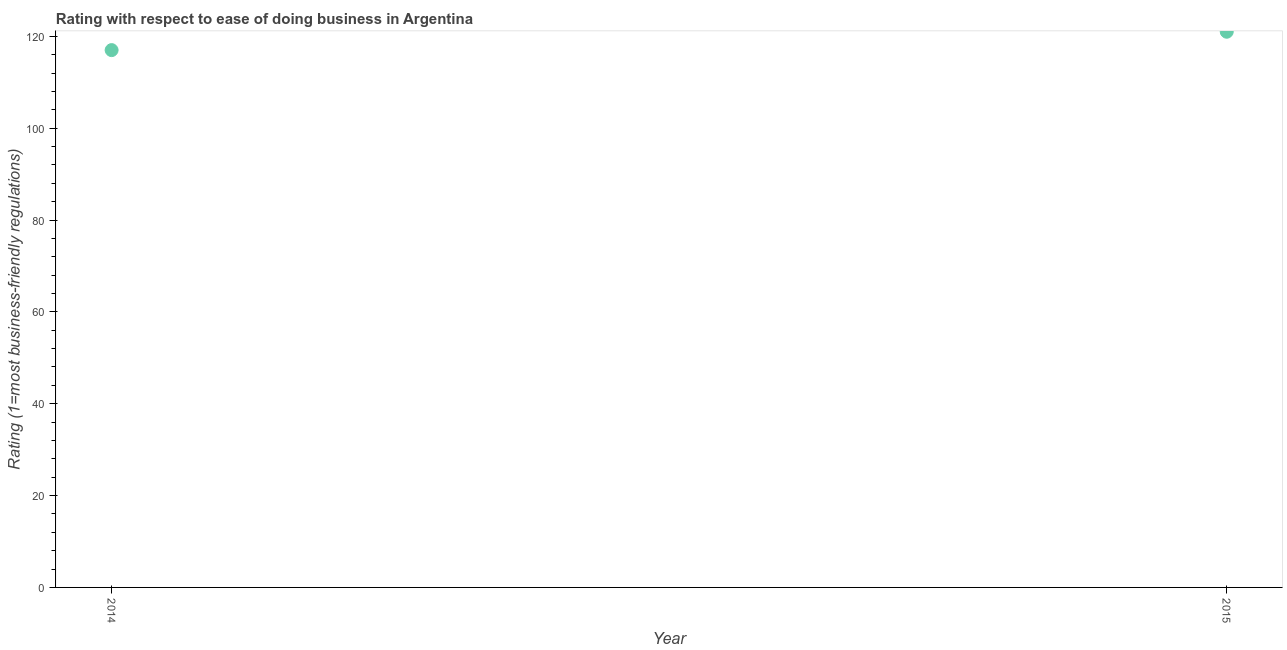What is the ease of doing business index in 2014?
Ensure brevity in your answer.  117. Across all years, what is the maximum ease of doing business index?
Your response must be concise. 121. Across all years, what is the minimum ease of doing business index?
Your response must be concise. 117. In which year was the ease of doing business index maximum?
Make the answer very short. 2015. In which year was the ease of doing business index minimum?
Give a very brief answer. 2014. What is the sum of the ease of doing business index?
Provide a succinct answer. 238. What is the difference between the ease of doing business index in 2014 and 2015?
Your response must be concise. -4. What is the average ease of doing business index per year?
Offer a terse response. 119. What is the median ease of doing business index?
Offer a terse response. 119. In how many years, is the ease of doing business index greater than 48 ?
Your answer should be very brief. 2. Do a majority of the years between 2015 and 2014 (inclusive) have ease of doing business index greater than 40 ?
Your response must be concise. No. What is the ratio of the ease of doing business index in 2014 to that in 2015?
Give a very brief answer. 0.97. Does the ease of doing business index monotonically increase over the years?
Provide a succinct answer. Yes. Are the values on the major ticks of Y-axis written in scientific E-notation?
Offer a terse response. No. Does the graph contain any zero values?
Your answer should be very brief. No. Does the graph contain grids?
Offer a very short reply. No. What is the title of the graph?
Ensure brevity in your answer.  Rating with respect to ease of doing business in Argentina. What is the label or title of the X-axis?
Provide a short and direct response. Year. What is the label or title of the Y-axis?
Offer a terse response. Rating (1=most business-friendly regulations). What is the Rating (1=most business-friendly regulations) in 2014?
Keep it short and to the point. 117. What is the Rating (1=most business-friendly regulations) in 2015?
Offer a very short reply. 121. 